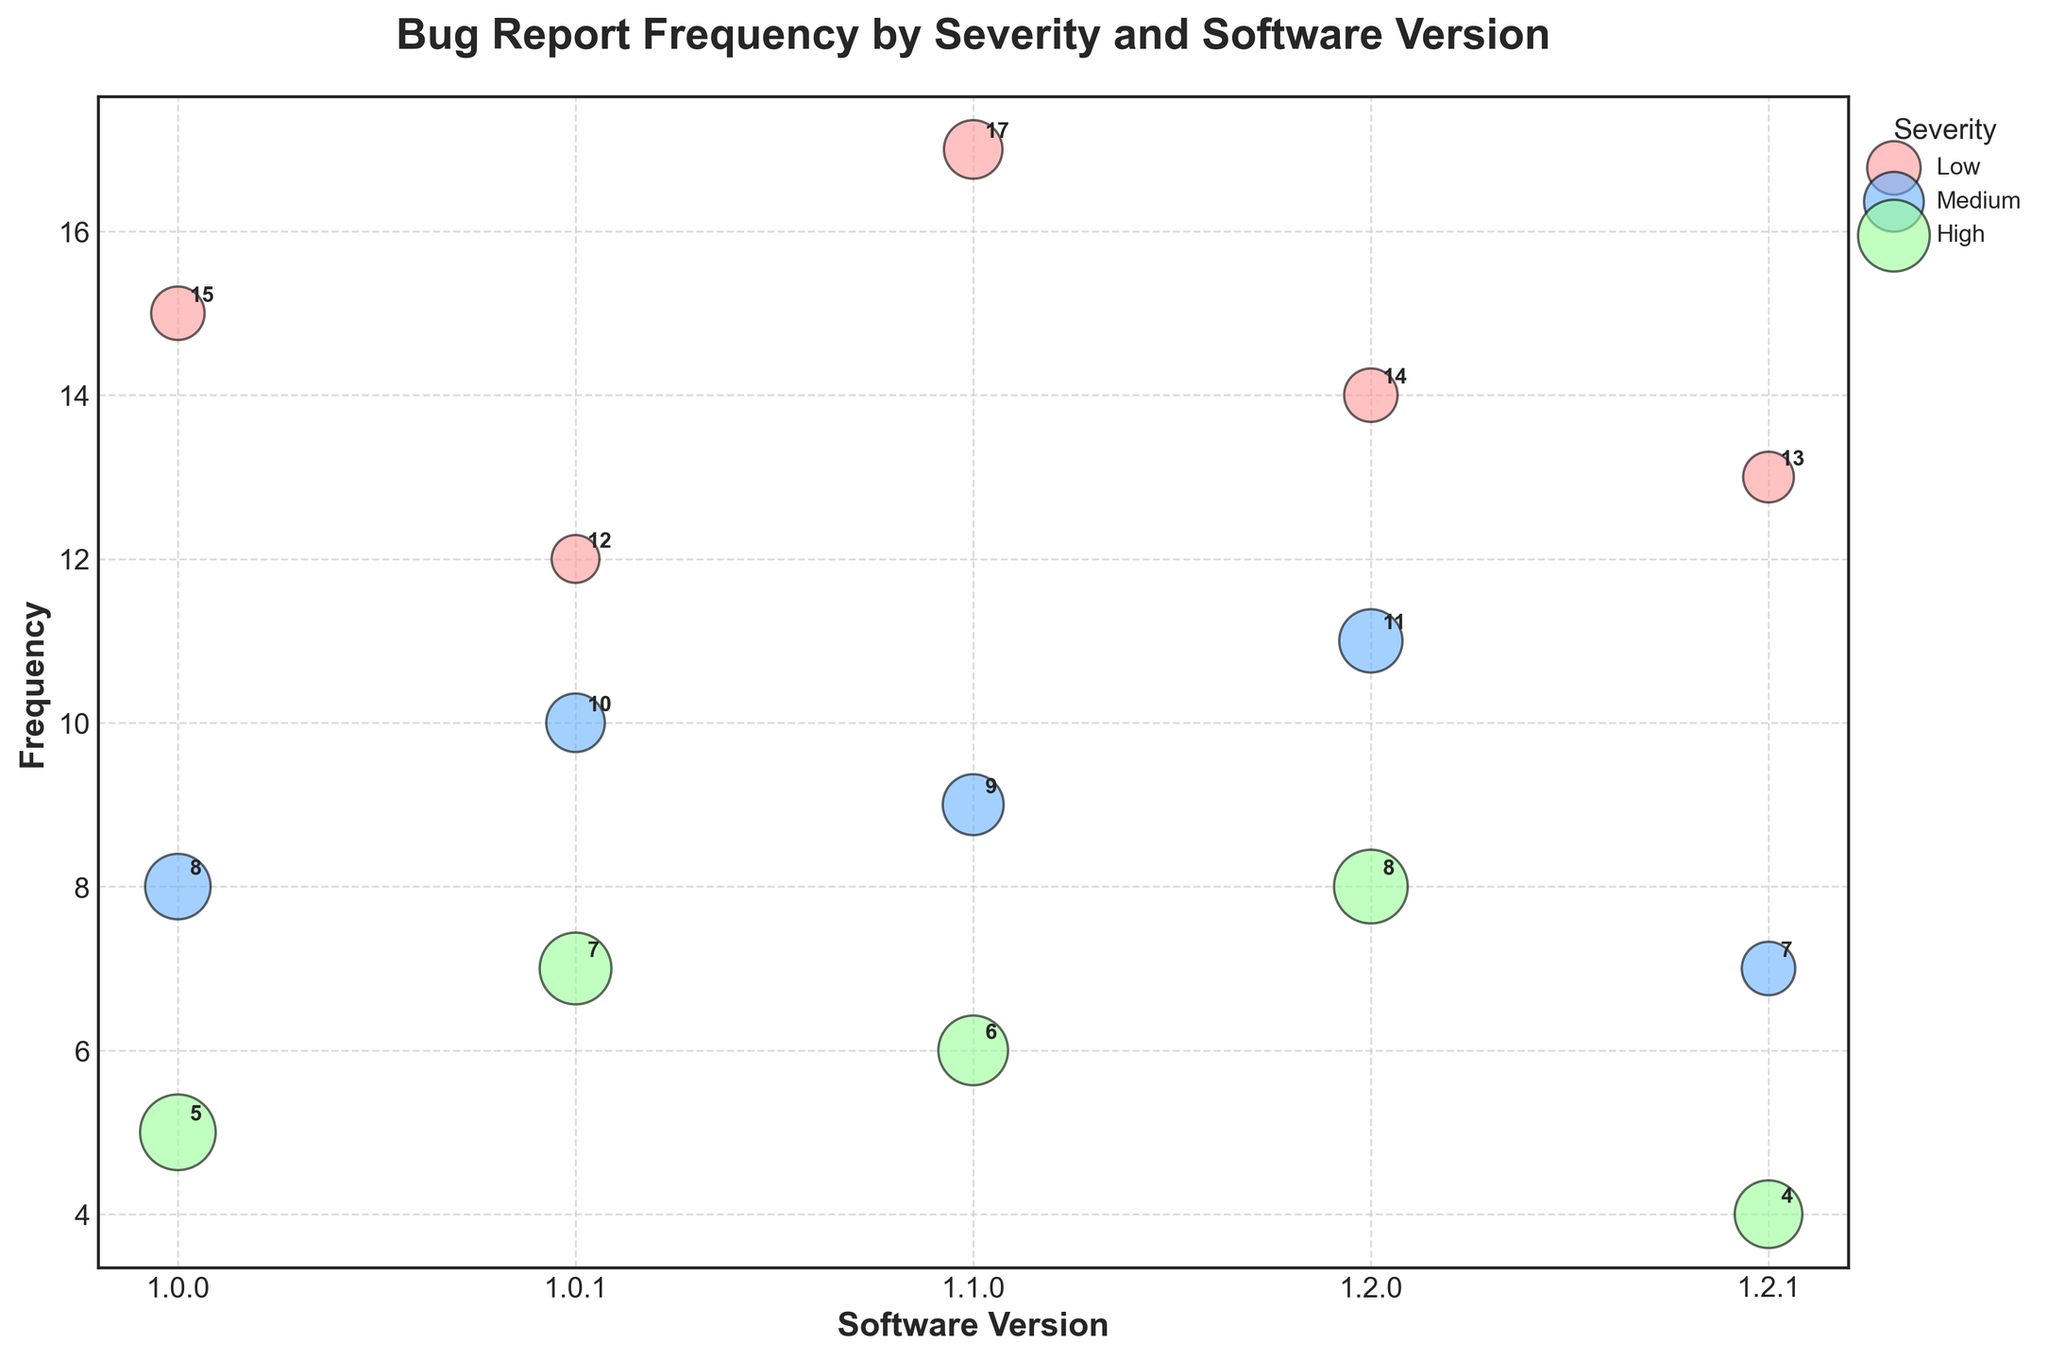What is the title of the figure? The title is usually written at the top of the figure in a larger, bold font. In this case, it is displayed as the central heading.
Answer: Bug Report Frequency by Severity and Software Version What are the labels of the x-axis and y-axis? Axis labels are usually located along each axis. The x-axis label is at the bottom, and the y-axis label is on the left side of the figure.
Answer: Software Version (x-axis), Frequency (y-axis) Which severity level has the highest frequency for software version 1.2.0? By looking at the bubble sizes and their y-axis values for software version 1.2.0, you can see which severity corresponds to the highest frequency.
Answer: Low How many severity levels are there? The legend on the figure indicates the different severity levels as they are referenced in the legend and color-coded.
Answer: 3 (Low, Medium, High) Which software version has the least high severity bug reports? By comparing the positions and sizes of the 'High' severity bubbles across all software versions, you can identify the software version with the least frequency.
Answer: 1.2.1 What is the total frequency of medium severity bug reports across all software versions? Sum the frequencies of medium severity bug reports from all software versions visible in the figure.
Answer: 45 Which severity of bug reports increases the most from version 1.0.0 to 1.2.0? Compare the frequency values for each severity (Low, Medium, High) between version 1.0.0 and 1.2.0 to find the one with the greatest increase.
Answer: Medium For software version 1.1.0, which severity level has the smallest bubble size? Inspect the bubble sizes corresponding to version 1.1.0 and identify which severity's bubble is the smallest.
Answer: High Is the frequency of bug reports generally increasing or decreasing over the software versions? Observe the trend of frequencies for each severity level across the versions to determine if there's an overall increase or decrease.
Answer: Increasing (generally) How does the frequency of low severity bug reports in version 1.0.0 compare to version 1.2.1? Compare the y-axis values (frequencies) of low severity in the given software versions.
Answer: 15 in 1.0.0, 13 in 1.2.1 